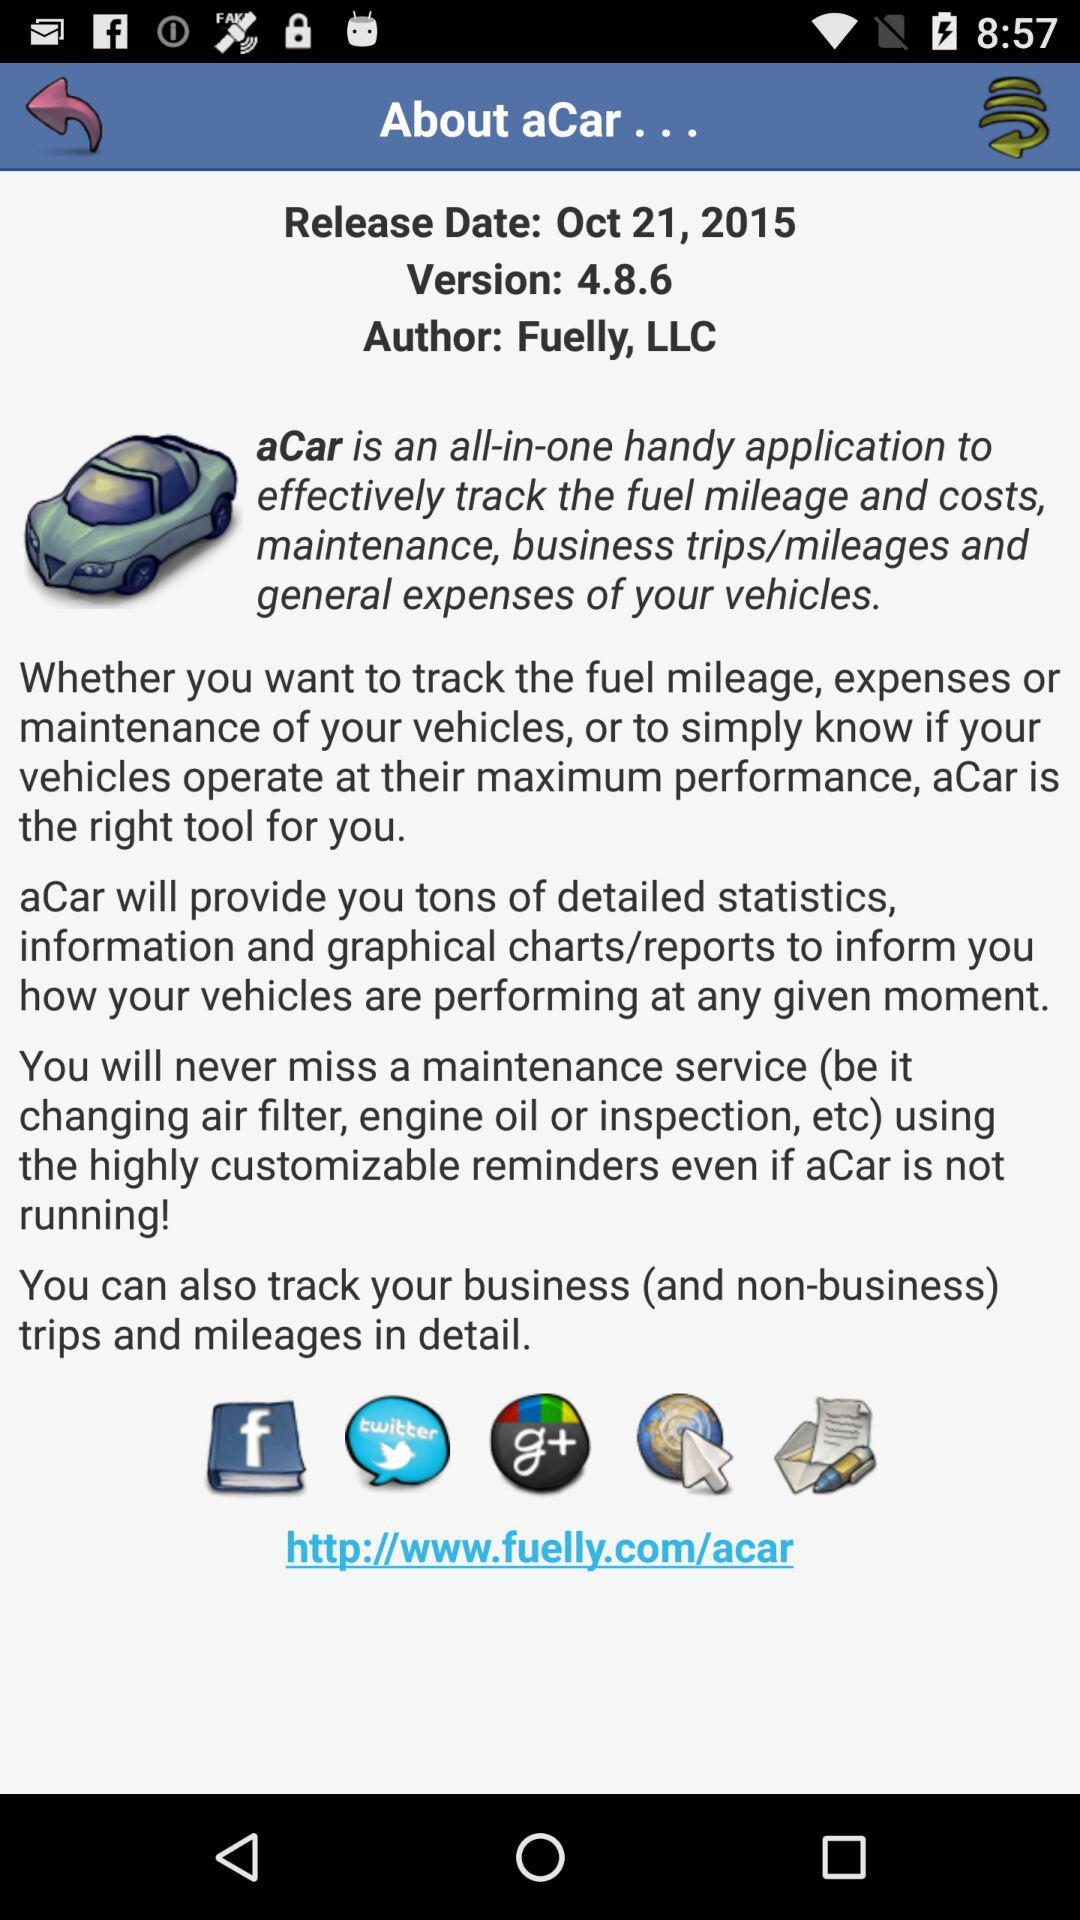What is the given version? The given version is 4.8.6. 